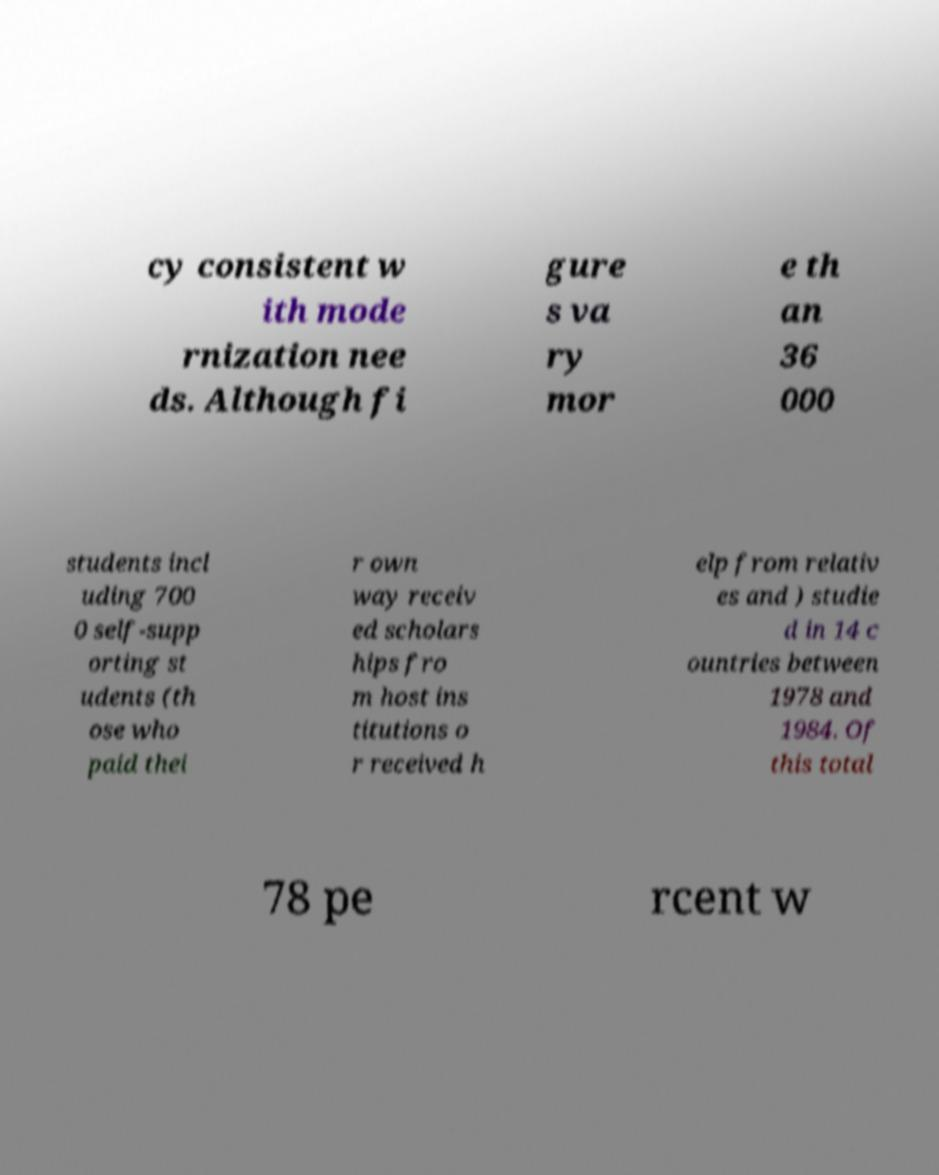There's text embedded in this image that I need extracted. Can you transcribe it verbatim? cy consistent w ith mode rnization nee ds. Although fi gure s va ry mor e th an 36 000 students incl uding 700 0 self-supp orting st udents (th ose who paid thei r own way receiv ed scholars hips fro m host ins titutions o r received h elp from relativ es and ) studie d in 14 c ountries between 1978 and 1984. Of this total 78 pe rcent w 